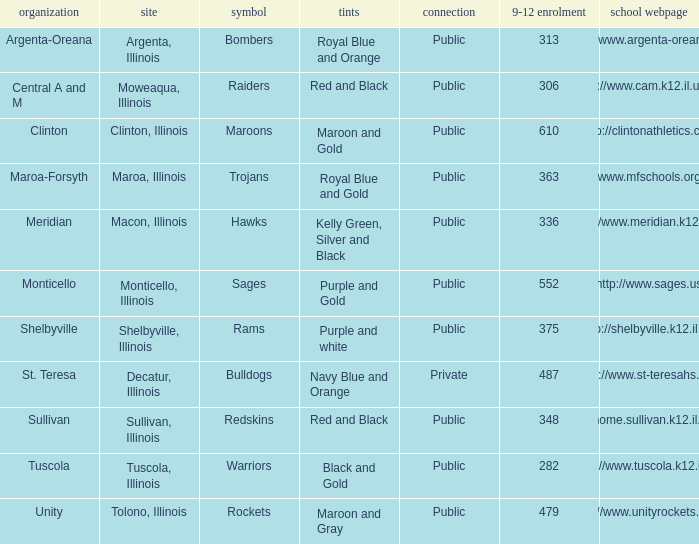What location has 363 students enrolled in the 9th to 12th grades? Maroa, Illinois. 